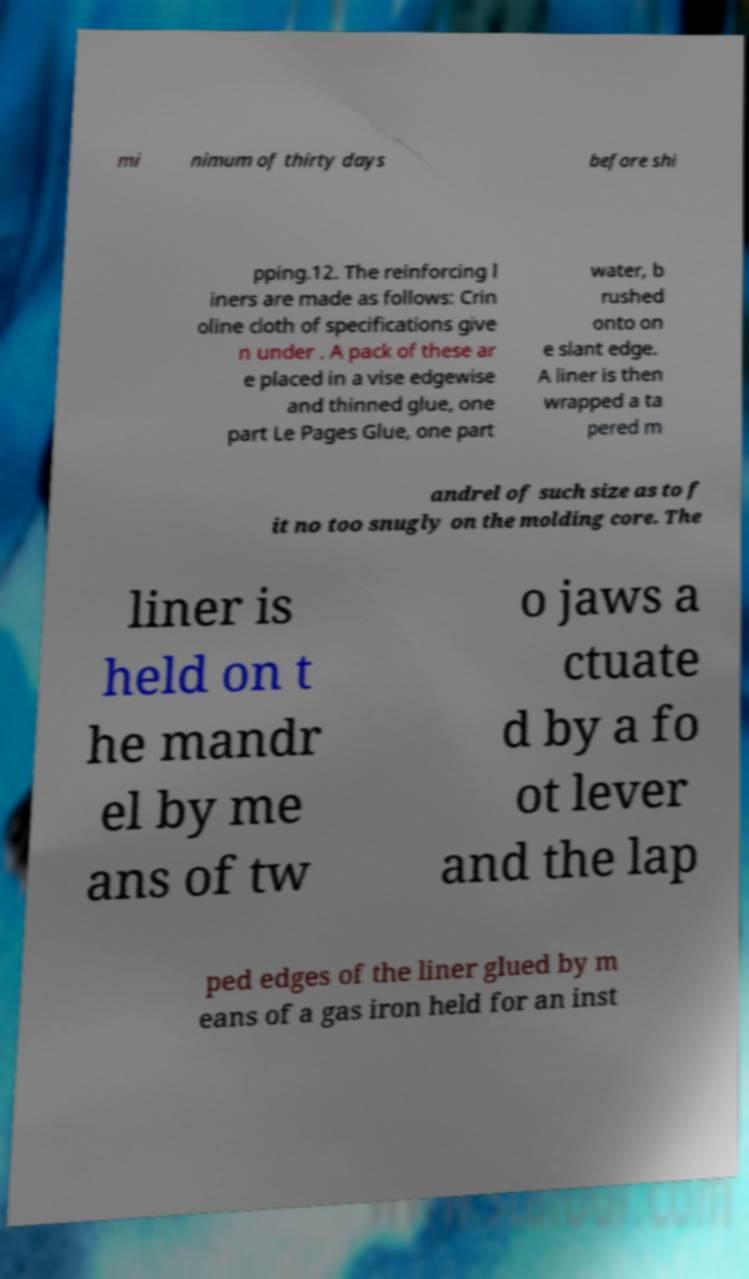I need the written content from this picture converted into text. Can you do that? mi nimum of thirty days before shi pping.12. The reinforcing l iners are made as follows: Crin oline cloth of specifications give n under . A pack of these ar e placed in a vise edgewise and thinned glue, one part Le Pages Glue, one part water, b rushed onto on e slant edge. A liner is then wrapped a ta pered m andrel of such size as to f it no too snugly on the molding core. The liner is held on t he mandr el by me ans of tw o jaws a ctuate d by a fo ot lever and the lap ped edges of the liner glued by m eans of a gas iron held for an inst 